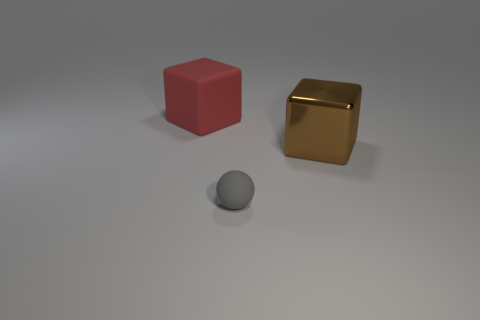Do the large red rubber object and the gray rubber thing have the same shape?
Offer a very short reply. No. What number of cubes are large cyan metallic things or brown things?
Your response must be concise. 1. What number of metallic objects are small red cylinders or tiny objects?
Your answer should be compact. 0. What size is the red thing that is the same shape as the brown thing?
Provide a succinct answer. Large. Is there anything else that is the same size as the ball?
Provide a succinct answer. No. There is a gray thing; is its size the same as the cube on the left side of the brown metal block?
Your response must be concise. No. What is the shape of the big object left of the large shiny block?
Keep it short and to the point. Cube. The big thing to the right of the matte object right of the red matte object is what color?
Your answer should be very brief. Brown. There is another big rubber object that is the same shape as the brown object; what color is it?
Provide a succinct answer. Red. Do the big rubber thing and the object in front of the big brown block have the same color?
Your answer should be compact. No. 